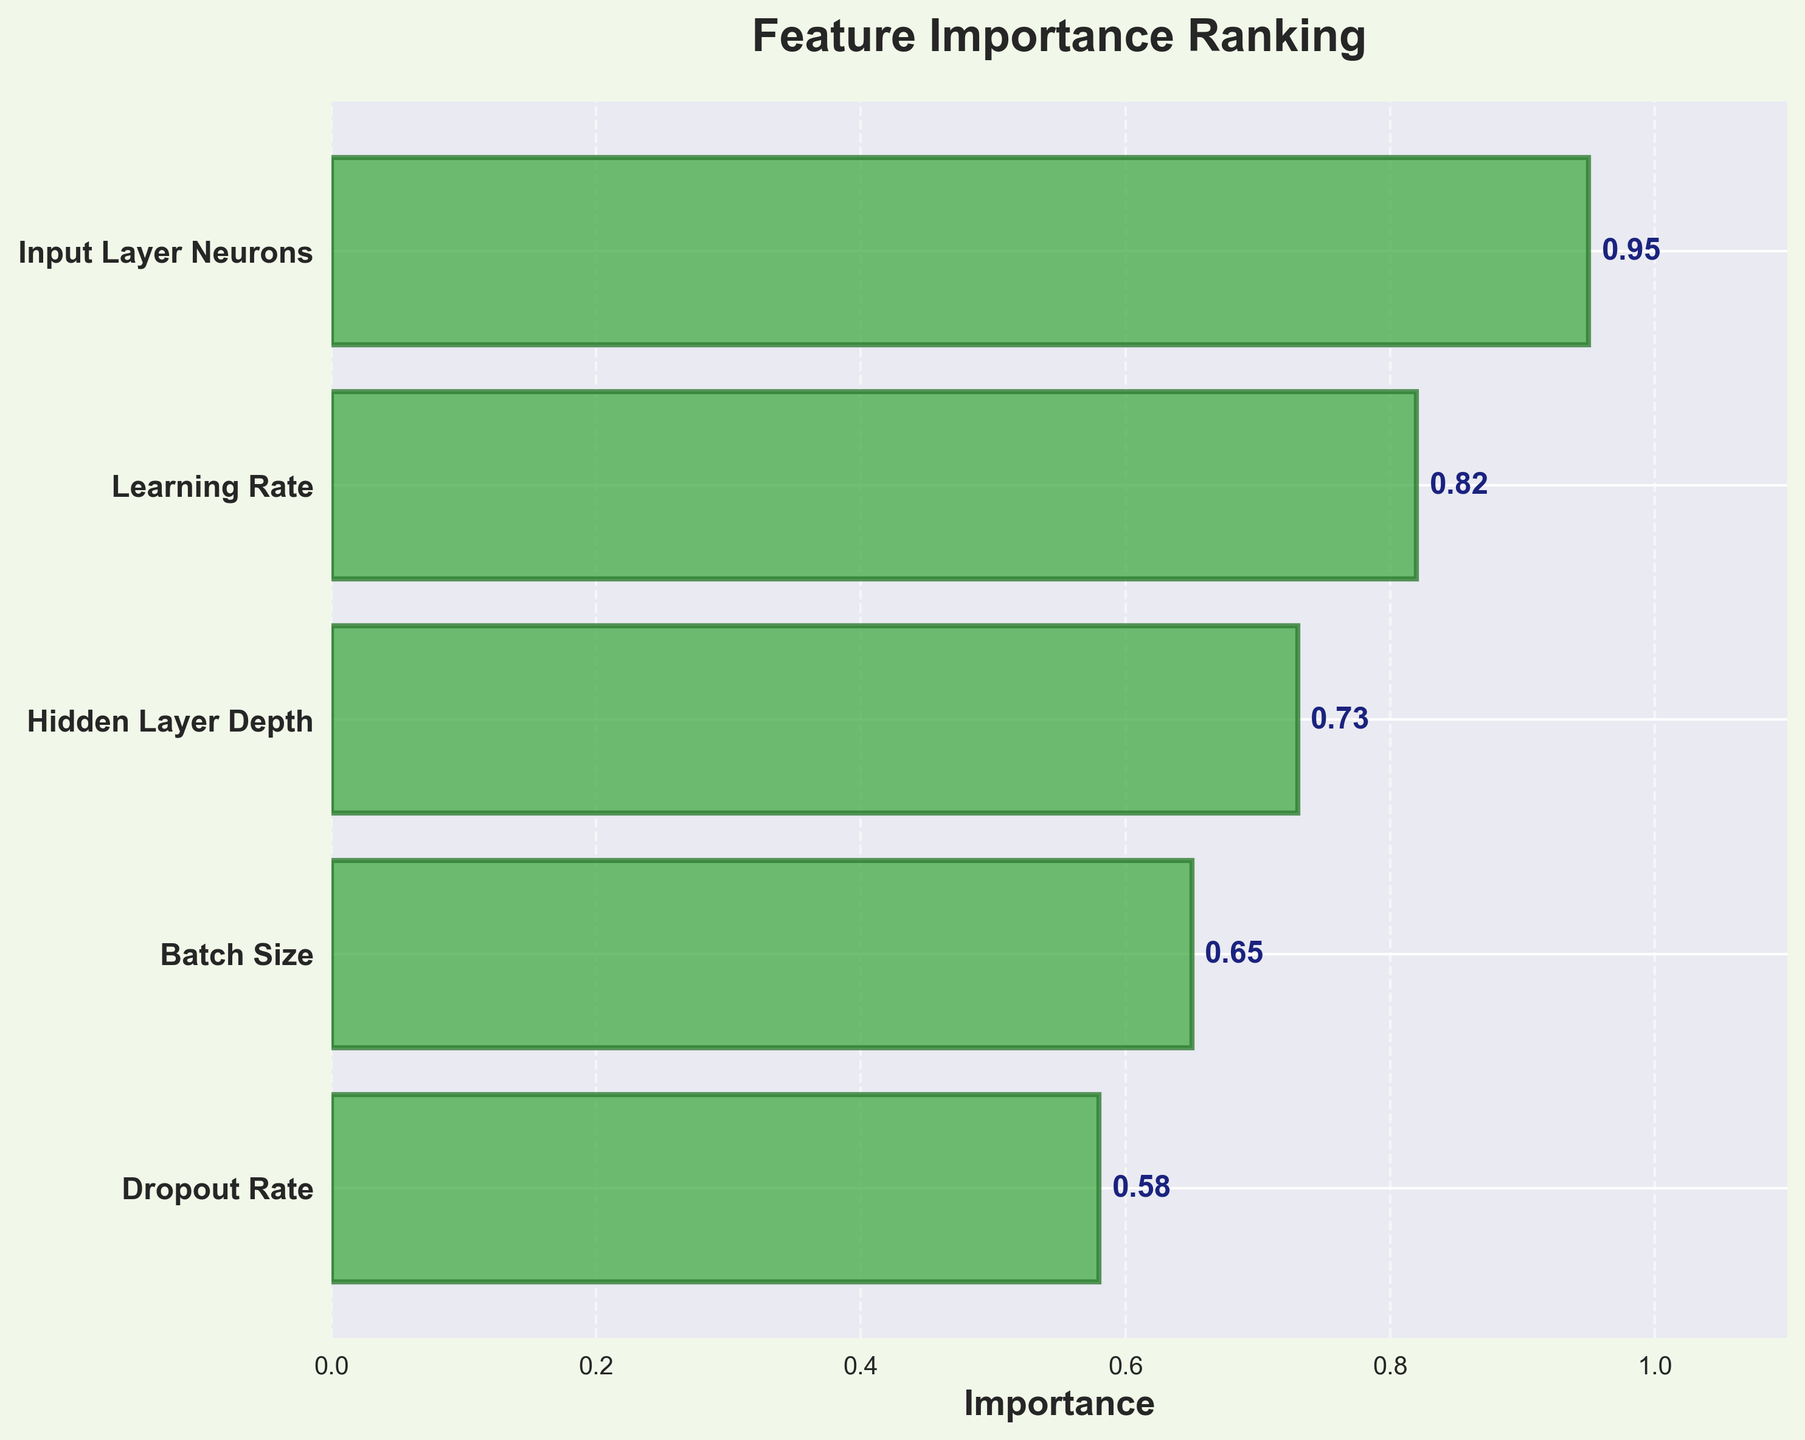What's the title of the chart? The title of the chart is written at the top and is bold. It indicates the main topic or focus of the chart.
Answer: Feature Importance Ranking How many features are displayed in the chart? You can count the number of y-axis labels in the chart to determine the number of features shown.
Answer: 5 Which feature has the highest importance value? Look for the bar that extends furthest to the right, representing the feature with the highest importance.
Answer: Input Layer Neurons What is the importance value of the Dropout Rate feature? Identify the bar representing "Dropout Rate" and look for its corresponding numerical value.
Answer: 0.58 Which feature ranks second in importance? Locate the second-longest bar on the chart to determine the feature with the second-highest importance.
Answer: Learning Rate What is the total combined importance of the top 3 features? Add the importance values of the top 3 features: Input Layer Neurons (0.95), Learning Rate (0.82), and Hidden Layer Depth (0.73). The sum will give the total combined importance.
Answer: 2.50 How much greater is the importance of the feature with the highest ranking compared to the feature with the lowest ranking? Subtract the importance value of Dropout Rate (0.58) from Input Layer Neurons (0.95).
Answer: 0.37 Which feature has a higher importance, Batch Size or Dropout Rate? Compare the lengths of the bars for Batch Size and Dropout Rate.
Answer: Batch Size What is the average importance value of all the features? Sum the importance values of all features and divide by the number of features: (0.95 + 0.82 + 0.73 + 0.65 + 0.58) / 5.
Answer: 0.75 